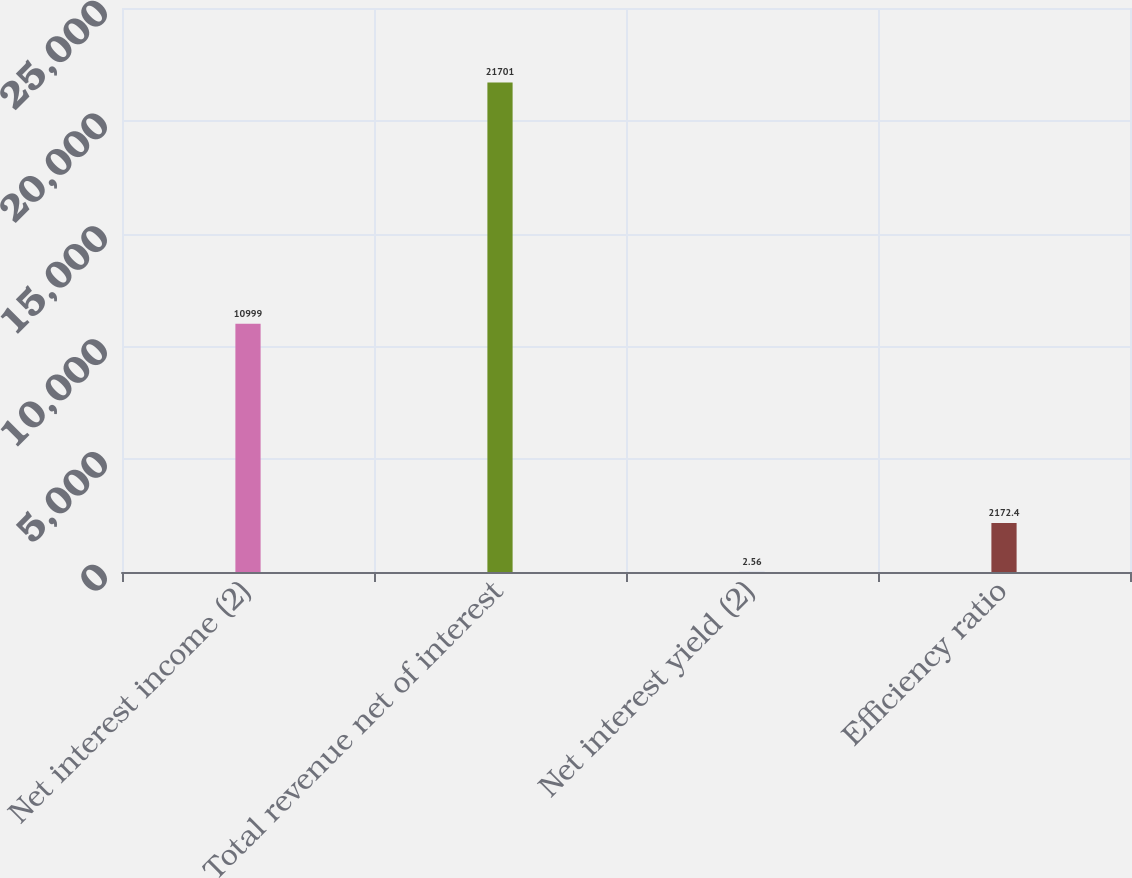<chart> <loc_0><loc_0><loc_500><loc_500><bar_chart><fcel>Net interest income (2)<fcel>Total revenue net of interest<fcel>Net interest yield (2)<fcel>Efficiency ratio<nl><fcel>10999<fcel>21701<fcel>2.56<fcel>2172.4<nl></chart> 